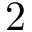Convert formula to latex. <formula><loc_0><loc_0><loc_500><loc_500>2</formula> 